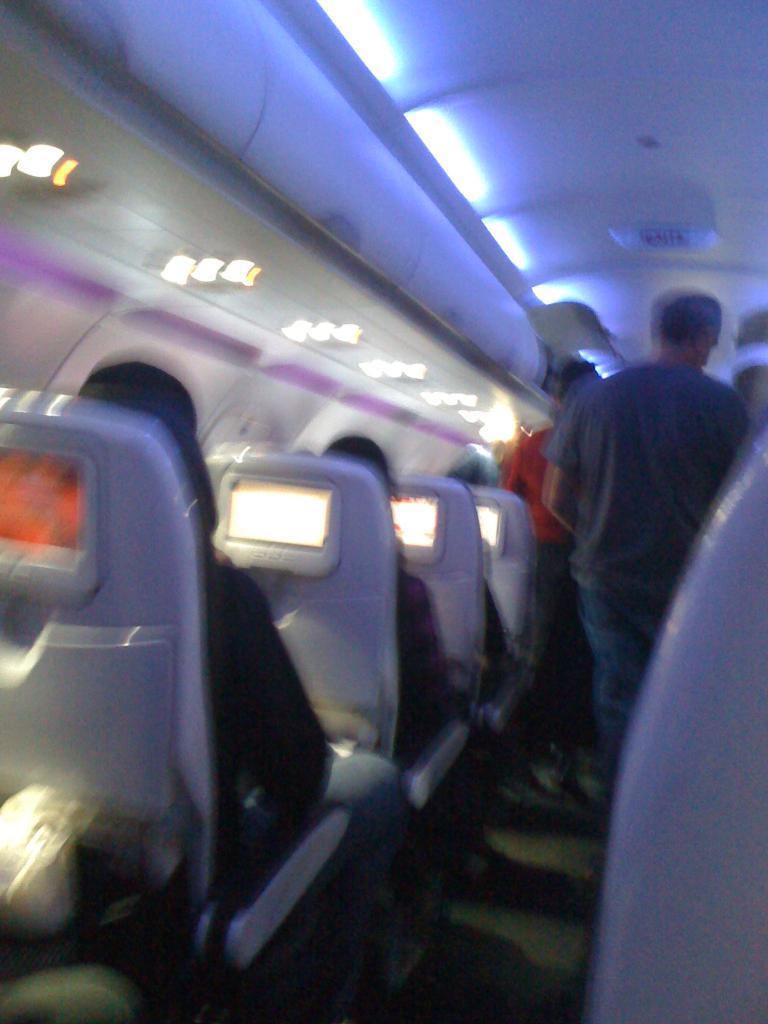How would you summarize this image in a sentence or two? It is a blur image, it looks like the picture is captured inside a plane, there are few people sitting on the chairs and beside them there are two people standing in the middle. 